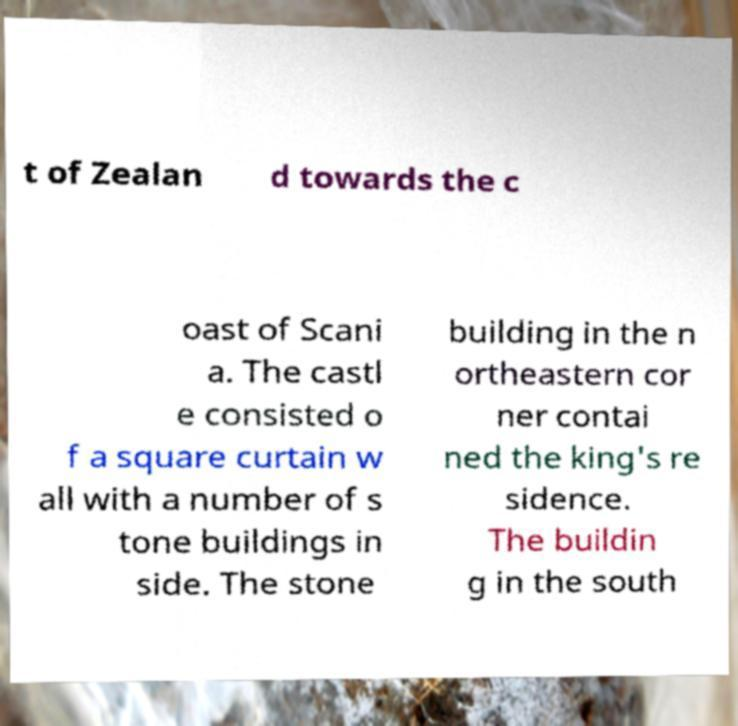For documentation purposes, I need the text within this image transcribed. Could you provide that? t of Zealan d towards the c oast of Scani a. The castl e consisted o f a square curtain w all with a number of s tone buildings in side. The stone building in the n ortheastern cor ner contai ned the king's re sidence. The buildin g in the south 